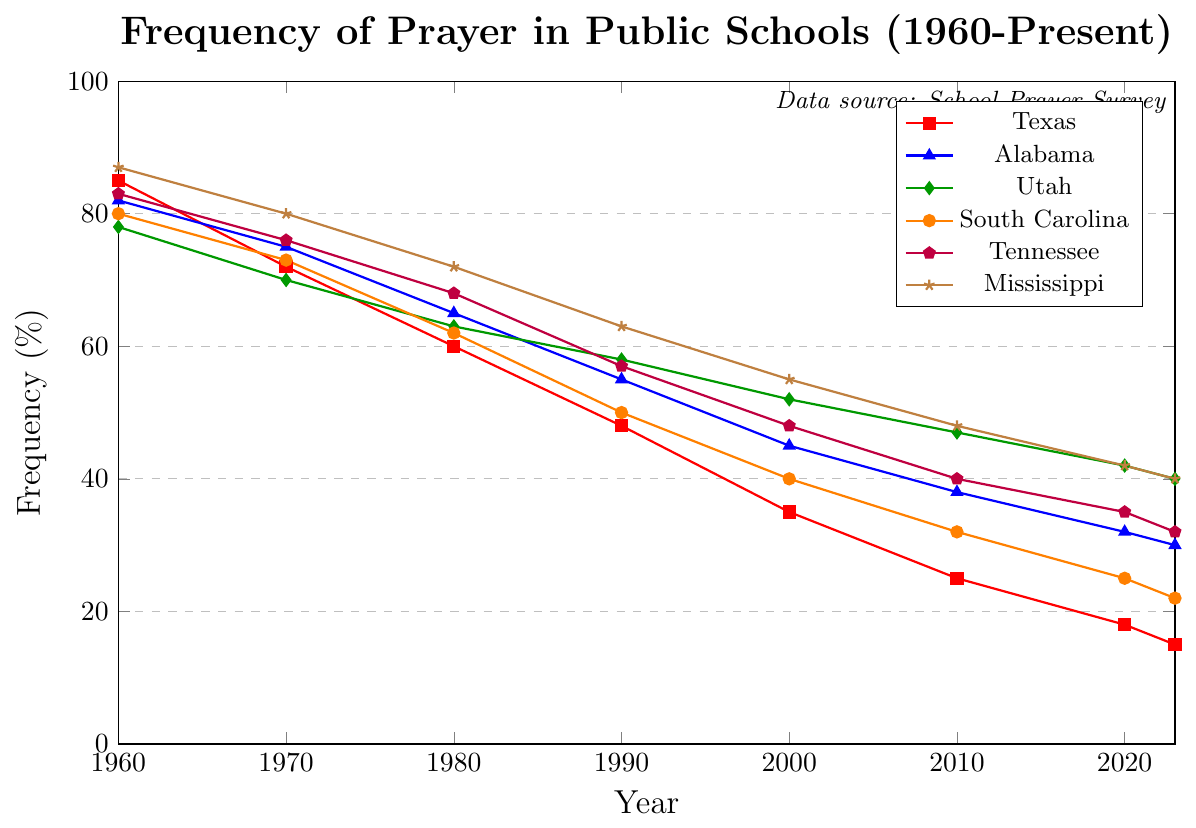What is the frequency of prayer in Utah in the present year? Look at the data point for Utah in the present year on the graph, which is marked in green.
Answer: 40 Comparing the years 1960 and 2023, what is the difference in the frequency of prayer in Texas? Locate the data points for Texas for the years 1960 and 2023 (85% and 15% respectively) and find the difference: 85 - 15 = 70.
Answer: 70 Which state had the highest frequency of prayer in 1960? Identify the maximum data point in 1960 by comparing the values: 85 (Texas), 82 (Alabama), 78 (Utah), 80 (South Carolina), 83 (Tennessee), 87 (Mississippi). Mississippi has the highest value.
Answer: Mississippi Which state experienced the largest decline in the frequency of prayer from 1960 to the present? Calculate the decline for each state: Texas (85-15=70), Alabama (82-30=52), Utah (78-40=38), South Carolina (80-22=58), Tennessee (83-32=51), Mississippi (87-40=47). The largest decline is in Texas with 70 points.
Answer: Texas In what decade did Tennessee see the most significant drop in prayer frequency? Examine the data points for Tennessee across each decade and find the biggest difference: From 1960 to 1970 (83-76=7), 1970 to 1980 (76-68=8), 1980 to 1990 (68-57=11), 1990 to 2000 (57-48=9), 2000 to 2010 (48-40=8), 2010 to 2020 (40-35=5), 2020 to 2023 (35-32=3). The largest drop is between 1980 and 1990 with a difference of 11.
Answer: 1980 to 1990 What is the average frequency of prayer in public schools in Mississippi over all the years shown? Calculate the mean value for Mississippi data: (87+80+72+63+55+48+42+40) / 8 = 487 / 8 = 60.875.
Answer: 60.875 How does Utah's frequency of prayer in 2020 compare to Alabama's in the same year? Locate the data points for Utah and Alabama in 2020 which are 42% and 32% respectively. Compare them to see that Utah has a higher value.
Answer: Utah's frequency is higher By how much did the frequency of prayer in South Carolina decrease from 1970 to 2000? Find the data points for South Carolina in 1970 and 2000 (73 and 40 respectively). The difference is 73 - 40 = 33.
Answer: 33 What are the colors representing Tennessee and South Carolina in the chart? Identify the colors used in the figure: Tennessee is marked in purple, and South Carolina is marked in orange.
Answer: Purple for Tennessee, Orange for South Carolina 